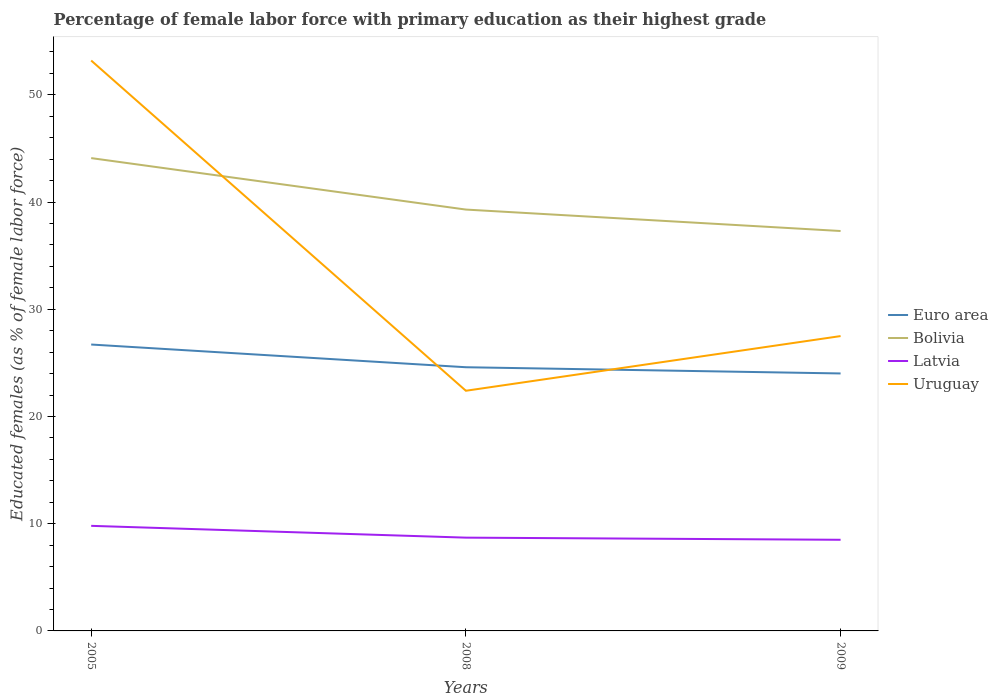How many different coloured lines are there?
Provide a succinct answer. 4. Does the line corresponding to Latvia intersect with the line corresponding to Bolivia?
Your answer should be very brief. No. Across all years, what is the maximum percentage of female labor force with primary education in Uruguay?
Give a very brief answer. 22.4. In which year was the percentage of female labor force with primary education in Euro area maximum?
Give a very brief answer. 2009. What is the total percentage of female labor force with primary education in Latvia in the graph?
Your response must be concise. 0.2. What is the difference between the highest and the second highest percentage of female labor force with primary education in Euro area?
Provide a succinct answer. 2.7. How many lines are there?
Give a very brief answer. 4. How many years are there in the graph?
Provide a succinct answer. 3. Are the values on the major ticks of Y-axis written in scientific E-notation?
Provide a short and direct response. No. Where does the legend appear in the graph?
Make the answer very short. Center right. How many legend labels are there?
Give a very brief answer. 4. What is the title of the graph?
Keep it short and to the point. Percentage of female labor force with primary education as their highest grade. Does "St. Martin (French part)" appear as one of the legend labels in the graph?
Make the answer very short. No. What is the label or title of the X-axis?
Give a very brief answer. Years. What is the label or title of the Y-axis?
Your answer should be compact. Educated females (as % of female labor force). What is the Educated females (as % of female labor force) of Euro area in 2005?
Ensure brevity in your answer.  26.71. What is the Educated females (as % of female labor force) in Bolivia in 2005?
Keep it short and to the point. 44.1. What is the Educated females (as % of female labor force) of Latvia in 2005?
Keep it short and to the point. 9.8. What is the Educated females (as % of female labor force) of Uruguay in 2005?
Make the answer very short. 53.2. What is the Educated females (as % of female labor force) of Euro area in 2008?
Your answer should be compact. 24.59. What is the Educated females (as % of female labor force) of Bolivia in 2008?
Provide a short and direct response. 39.3. What is the Educated females (as % of female labor force) in Latvia in 2008?
Offer a very short reply. 8.7. What is the Educated females (as % of female labor force) of Uruguay in 2008?
Offer a terse response. 22.4. What is the Educated females (as % of female labor force) of Euro area in 2009?
Give a very brief answer. 24.01. What is the Educated females (as % of female labor force) in Bolivia in 2009?
Your answer should be very brief. 37.3. Across all years, what is the maximum Educated females (as % of female labor force) of Euro area?
Make the answer very short. 26.71. Across all years, what is the maximum Educated females (as % of female labor force) of Bolivia?
Your response must be concise. 44.1. Across all years, what is the maximum Educated females (as % of female labor force) of Latvia?
Your answer should be very brief. 9.8. Across all years, what is the maximum Educated females (as % of female labor force) in Uruguay?
Provide a succinct answer. 53.2. Across all years, what is the minimum Educated females (as % of female labor force) in Euro area?
Provide a short and direct response. 24.01. Across all years, what is the minimum Educated females (as % of female labor force) of Bolivia?
Your answer should be compact. 37.3. Across all years, what is the minimum Educated females (as % of female labor force) in Latvia?
Give a very brief answer. 8.5. Across all years, what is the minimum Educated females (as % of female labor force) in Uruguay?
Your answer should be very brief. 22.4. What is the total Educated females (as % of female labor force) of Euro area in the graph?
Your answer should be very brief. 75.32. What is the total Educated females (as % of female labor force) in Bolivia in the graph?
Make the answer very short. 120.7. What is the total Educated females (as % of female labor force) of Latvia in the graph?
Ensure brevity in your answer.  27. What is the total Educated females (as % of female labor force) in Uruguay in the graph?
Ensure brevity in your answer.  103.1. What is the difference between the Educated females (as % of female labor force) in Euro area in 2005 and that in 2008?
Provide a succinct answer. 2.12. What is the difference between the Educated females (as % of female labor force) of Latvia in 2005 and that in 2008?
Make the answer very short. 1.1. What is the difference between the Educated females (as % of female labor force) in Uruguay in 2005 and that in 2008?
Offer a terse response. 30.8. What is the difference between the Educated females (as % of female labor force) in Euro area in 2005 and that in 2009?
Your answer should be compact. 2.7. What is the difference between the Educated females (as % of female labor force) of Bolivia in 2005 and that in 2009?
Offer a very short reply. 6.8. What is the difference between the Educated females (as % of female labor force) of Uruguay in 2005 and that in 2009?
Offer a terse response. 25.7. What is the difference between the Educated females (as % of female labor force) in Euro area in 2008 and that in 2009?
Provide a succinct answer. 0.58. What is the difference between the Educated females (as % of female labor force) in Bolivia in 2008 and that in 2009?
Your response must be concise. 2. What is the difference between the Educated females (as % of female labor force) in Latvia in 2008 and that in 2009?
Keep it short and to the point. 0.2. What is the difference between the Educated females (as % of female labor force) in Uruguay in 2008 and that in 2009?
Provide a short and direct response. -5.1. What is the difference between the Educated females (as % of female labor force) of Euro area in 2005 and the Educated females (as % of female labor force) of Bolivia in 2008?
Make the answer very short. -12.59. What is the difference between the Educated females (as % of female labor force) in Euro area in 2005 and the Educated females (as % of female labor force) in Latvia in 2008?
Offer a terse response. 18.01. What is the difference between the Educated females (as % of female labor force) in Euro area in 2005 and the Educated females (as % of female labor force) in Uruguay in 2008?
Keep it short and to the point. 4.31. What is the difference between the Educated females (as % of female labor force) in Bolivia in 2005 and the Educated females (as % of female labor force) in Latvia in 2008?
Make the answer very short. 35.4. What is the difference between the Educated females (as % of female labor force) in Bolivia in 2005 and the Educated females (as % of female labor force) in Uruguay in 2008?
Your answer should be very brief. 21.7. What is the difference between the Educated females (as % of female labor force) in Euro area in 2005 and the Educated females (as % of female labor force) in Bolivia in 2009?
Your answer should be very brief. -10.59. What is the difference between the Educated females (as % of female labor force) in Euro area in 2005 and the Educated females (as % of female labor force) in Latvia in 2009?
Offer a very short reply. 18.21. What is the difference between the Educated females (as % of female labor force) of Euro area in 2005 and the Educated females (as % of female labor force) of Uruguay in 2009?
Provide a short and direct response. -0.79. What is the difference between the Educated females (as % of female labor force) of Bolivia in 2005 and the Educated females (as % of female labor force) of Latvia in 2009?
Offer a very short reply. 35.6. What is the difference between the Educated females (as % of female labor force) of Bolivia in 2005 and the Educated females (as % of female labor force) of Uruguay in 2009?
Keep it short and to the point. 16.6. What is the difference between the Educated females (as % of female labor force) in Latvia in 2005 and the Educated females (as % of female labor force) in Uruguay in 2009?
Provide a succinct answer. -17.7. What is the difference between the Educated females (as % of female labor force) in Euro area in 2008 and the Educated females (as % of female labor force) in Bolivia in 2009?
Keep it short and to the point. -12.71. What is the difference between the Educated females (as % of female labor force) in Euro area in 2008 and the Educated females (as % of female labor force) in Latvia in 2009?
Make the answer very short. 16.09. What is the difference between the Educated females (as % of female labor force) in Euro area in 2008 and the Educated females (as % of female labor force) in Uruguay in 2009?
Provide a succinct answer. -2.91. What is the difference between the Educated females (as % of female labor force) in Bolivia in 2008 and the Educated females (as % of female labor force) in Latvia in 2009?
Provide a short and direct response. 30.8. What is the difference between the Educated females (as % of female labor force) of Latvia in 2008 and the Educated females (as % of female labor force) of Uruguay in 2009?
Make the answer very short. -18.8. What is the average Educated females (as % of female labor force) of Euro area per year?
Offer a very short reply. 25.11. What is the average Educated females (as % of female labor force) of Bolivia per year?
Your response must be concise. 40.23. What is the average Educated females (as % of female labor force) in Latvia per year?
Provide a short and direct response. 9. What is the average Educated females (as % of female labor force) in Uruguay per year?
Keep it short and to the point. 34.37. In the year 2005, what is the difference between the Educated females (as % of female labor force) of Euro area and Educated females (as % of female labor force) of Bolivia?
Your response must be concise. -17.39. In the year 2005, what is the difference between the Educated females (as % of female labor force) of Euro area and Educated females (as % of female labor force) of Latvia?
Offer a very short reply. 16.91. In the year 2005, what is the difference between the Educated females (as % of female labor force) in Euro area and Educated females (as % of female labor force) in Uruguay?
Provide a short and direct response. -26.49. In the year 2005, what is the difference between the Educated females (as % of female labor force) of Bolivia and Educated females (as % of female labor force) of Latvia?
Your answer should be compact. 34.3. In the year 2005, what is the difference between the Educated females (as % of female labor force) of Bolivia and Educated females (as % of female labor force) of Uruguay?
Offer a terse response. -9.1. In the year 2005, what is the difference between the Educated females (as % of female labor force) in Latvia and Educated females (as % of female labor force) in Uruguay?
Your response must be concise. -43.4. In the year 2008, what is the difference between the Educated females (as % of female labor force) in Euro area and Educated females (as % of female labor force) in Bolivia?
Provide a short and direct response. -14.71. In the year 2008, what is the difference between the Educated females (as % of female labor force) in Euro area and Educated females (as % of female labor force) in Latvia?
Offer a terse response. 15.89. In the year 2008, what is the difference between the Educated females (as % of female labor force) in Euro area and Educated females (as % of female labor force) in Uruguay?
Ensure brevity in your answer.  2.19. In the year 2008, what is the difference between the Educated females (as % of female labor force) in Bolivia and Educated females (as % of female labor force) in Latvia?
Provide a succinct answer. 30.6. In the year 2008, what is the difference between the Educated females (as % of female labor force) of Latvia and Educated females (as % of female labor force) of Uruguay?
Provide a short and direct response. -13.7. In the year 2009, what is the difference between the Educated females (as % of female labor force) in Euro area and Educated females (as % of female labor force) in Bolivia?
Provide a succinct answer. -13.29. In the year 2009, what is the difference between the Educated females (as % of female labor force) of Euro area and Educated females (as % of female labor force) of Latvia?
Offer a very short reply. 15.51. In the year 2009, what is the difference between the Educated females (as % of female labor force) of Euro area and Educated females (as % of female labor force) of Uruguay?
Make the answer very short. -3.49. In the year 2009, what is the difference between the Educated females (as % of female labor force) of Bolivia and Educated females (as % of female labor force) of Latvia?
Give a very brief answer. 28.8. In the year 2009, what is the difference between the Educated females (as % of female labor force) of Latvia and Educated females (as % of female labor force) of Uruguay?
Make the answer very short. -19. What is the ratio of the Educated females (as % of female labor force) of Euro area in 2005 to that in 2008?
Your answer should be compact. 1.09. What is the ratio of the Educated females (as % of female labor force) in Bolivia in 2005 to that in 2008?
Ensure brevity in your answer.  1.12. What is the ratio of the Educated females (as % of female labor force) of Latvia in 2005 to that in 2008?
Ensure brevity in your answer.  1.13. What is the ratio of the Educated females (as % of female labor force) in Uruguay in 2005 to that in 2008?
Ensure brevity in your answer.  2.38. What is the ratio of the Educated females (as % of female labor force) of Euro area in 2005 to that in 2009?
Your answer should be very brief. 1.11. What is the ratio of the Educated females (as % of female labor force) of Bolivia in 2005 to that in 2009?
Offer a very short reply. 1.18. What is the ratio of the Educated females (as % of female labor force) of Latvia in 2005 to that in 2009?
Make the answer very short. 1.15. What is the ratio of the Educated females (as % of female labor force) of Uruguay in 2005 to that in 2009?
Your response must be concise. 1.93. What is the ratio of the Educated females (as % of female labor force) in Euro area in 2008 to that in 2009?
Make the answer very short. 1.02. What is the ratio of the Educated females (as % of female labor force) of Bolivia in 2008 to that in 2009?
Your answer should be very brief. 1.05. What is the ratio of the Educated females (as % of female labor force) of Latvia in 2008 to that in 2009?
Keep it short and to the point. 1.02. What is the ratio of the Educated females (as % of female labor force) in Uruguay in 2008 to that in 2009?
Keep it short and to the point. 0.81. What is the difference between the highest and the second highest Educated females (as % of female labor force) of Euro area?
Your answer should be compact. 2.12. What is the difference between the highest and the second highest Educated females (as % of female labor force) of Uruguay?
Provide a succinct answer. 25.7. What is the difference between the highest and the lowest Educated females (as % of female labor force) in Euro area?
Offer a very short reply. 2.7. What is the difference between the highest and the lowest Educated females (as % of female labor force) in Uruguay?
Your response must be concise. 30.8. 